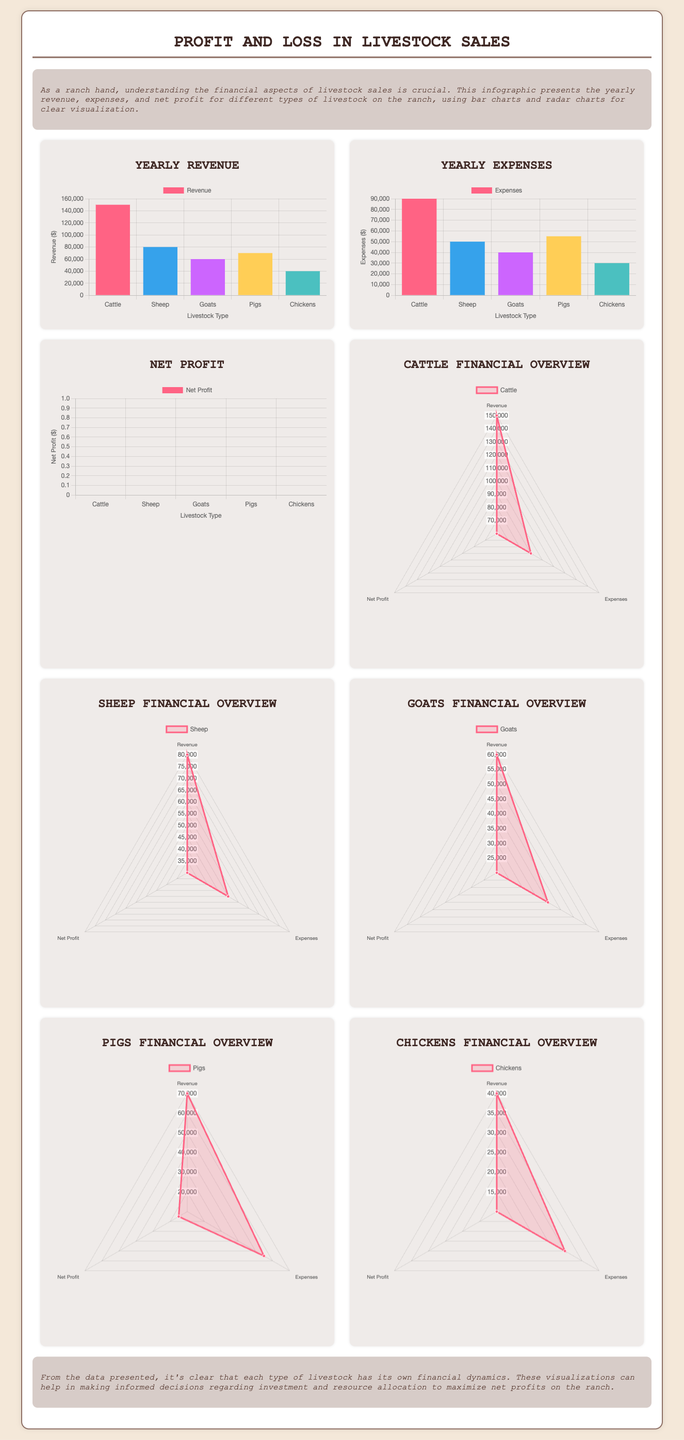What is the total revenue from cattle? The total revenue from cattle is directly shown on the revenue chart.
Answer: 150000 What are the yearly expenses for pigs? The yearly expenses for pigs can be found in the expenses chart.
Answer: 55000 Which type of livestock has the highest net profit? The highest net profit can be determined by comparing the net profit results on the profit chart.
Answer: Cattle What is the total net profit for goats? The net profit for goats is explicitly indicated in the net profit chart.
Answer: 20000 Which livestock type has the lowest revenue? The lowest revenue is identified by analyzing the revenue chart for the livestock types.
Answer: Chickens How much did sheep contribute to the overall revenue? The contribution of sheep to the overall revenue is found in the revenue chart.
Answer: 80000 What is the relationship between expenses and net profit for chickens? The relationship can be assessed by comparing the expenses and net profit figures for chickens in their respective charts.
Answer: Higher expenses lead to lower net profit Which livestock type shows a balanced profit and loss situation? A balanced situation can be determined by examining net profit in relation to revenue and expenses across all types.
Answer: Sheep What type of chart is used to represent financial overview for livestock? The type of chart used for the financial overview is specified in the document.
Answer: Radar chart 